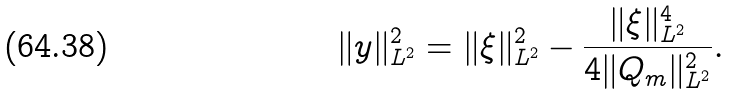Convert formula to latex. <formula><loc_0><loc_0><loc_500><loc_500>\| y \| _ { L ^ { 2 } } ^ { 2 } = \| \xi \| _ { L ^ { 2 } } ^ { 2 } - \frac { \| \xi \| _ { L ^ { 2 } } ^ { 4 } } { 4 \| Q _ { m } \| _ { L ^ { 2 } } ^ { 2 } } .</formula> 